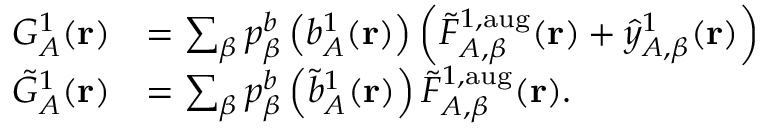Convert formula to latex. <formula><loc_0><loc_0><loc_500><loc_500>\begin{array} { r l } { G _ { A } ^ { 1 } ( r ) } & { = \sum _ { \beta } p _ { \beta } ^ { b } \left ( b _ { A } ^ { 1 } ( r ) \right ) \left ( \tilde { F } _ { A , \beta } ^ { 1 , a u g } ( r ) + \hat { y } _ { A , \beta } ^ { 1 } ( r ) \right ) } \\ { \tilde { G } _ { A } ^ { 1 } ( r ) } & { = \sum _ { \beta } p _ { \beta } ^ { b } \left ( \tilde { b } _ { A } ^ { 1 } ( r ) \right ) \tilde { F } _ { A , \beta } ^ { 1 , a u g } ( r ) . } \end{array}</formula> 